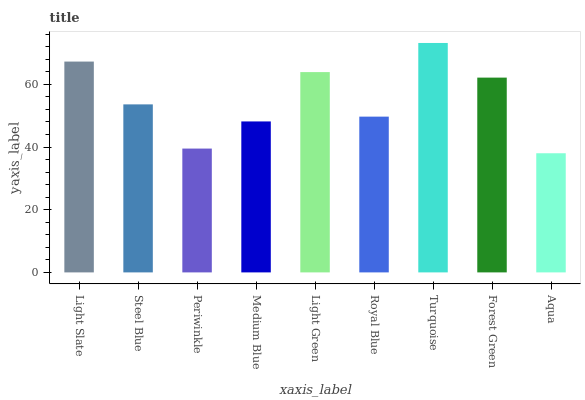Is Aqua the minimum?
Answer yes or no. Yes. Is Turquoise the maximum?
Answer yes or no. Yes. Is Steel Blue the minimum?
Answer yes or no. No. Is Steel Blue the maximum?
Answer yes or no. No. Is Light Slate greater than Steel Blue?
Answer yes or no. Yes. Is Steel Blue less than Light Slate?
Answer yes or no. Yes. Is Steel Blue greater than Light Slate?
Answer yes or no. No. Is Light Slate less than Steel Blue?
Answer yes or no. No. Is Steel Blue the high median?
Answer yes or no. Yes. Is Steel Blue the low median?
Answer yes or no. Yes. Is Aqua the high median?
Answer yes or no. No. Is Medium Blue the low median?
Answer yes or no. No. 